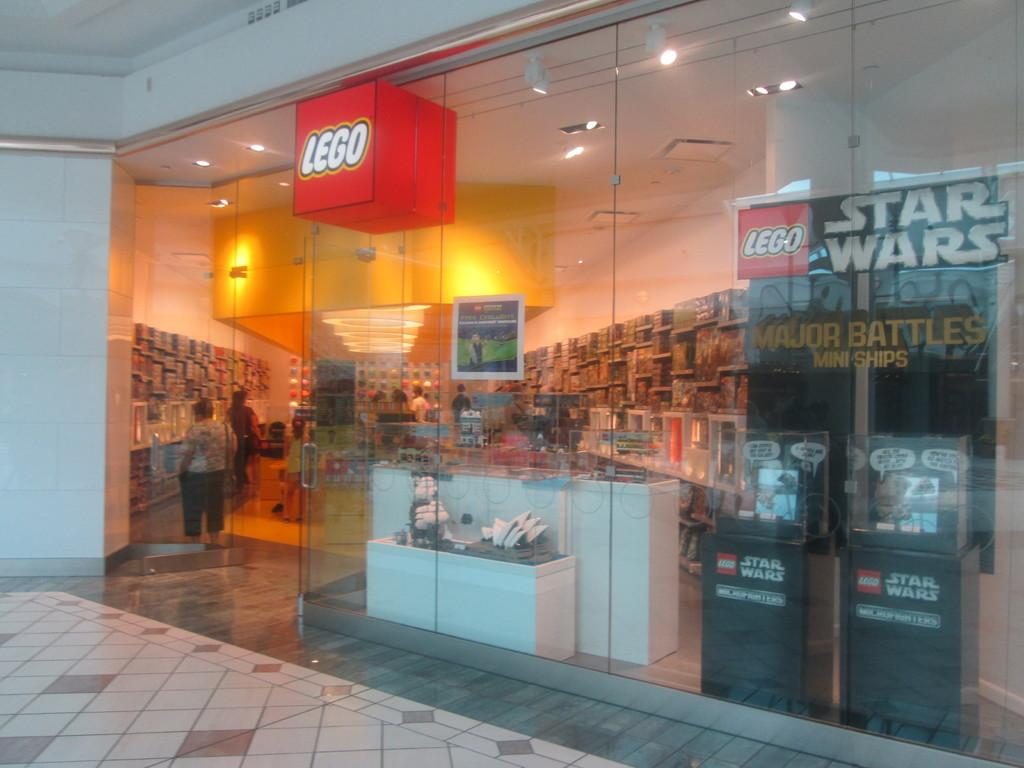What type of establishment is located in the center of the image? There is a store in the center of the image. What is associated with the store in the image? There is a board associated with the store. What surface can be seen in the image? There is a floor visible in the image. What is the entrance to the store like? There is a door in the image. Can you describe what is visible beyond the door? People are visible through the door. What type of butter is being used to hold the chain together in the image? There is no butter or chain present in the image. 